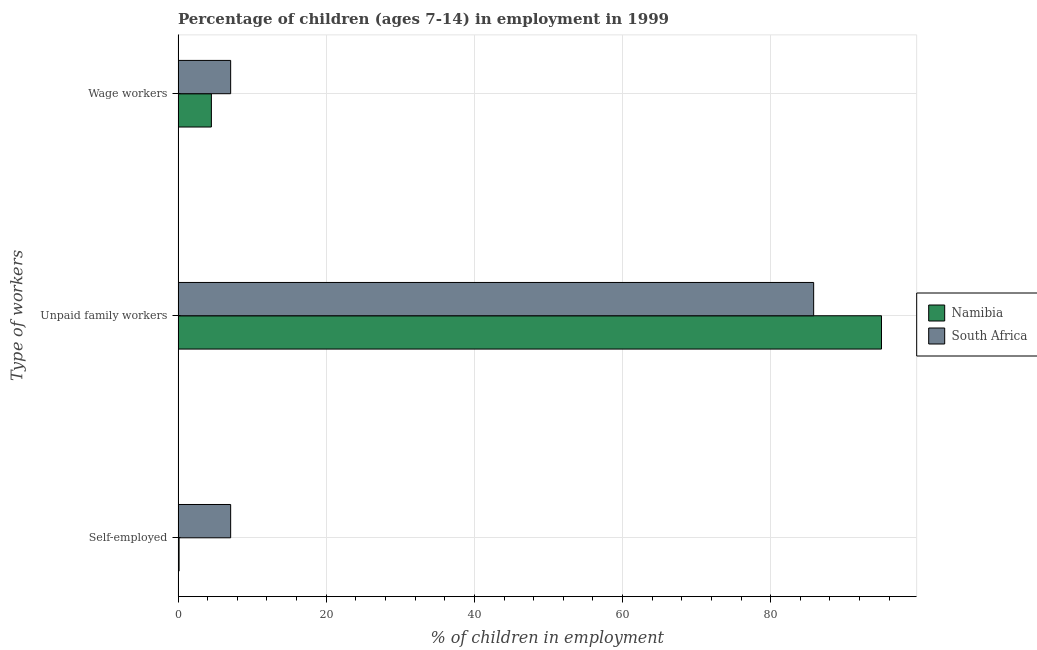How many groups of bars are there?
Provide a succinct answer. 3. Are the number of bars on each tick of the Y-axis equal?
Your response must be concise. Yes. How many bars are there on the 3rd tick from the top?
Keep it short and to the point. 2. How many bars are there on the 1st tick from the bottom?
Your answer should be compact. 2. What is the label of the 2nd group of bars from the top?
Give a very brief answer. Unpaid family workers. Across all countries, what is the maximum percentage of self employed children?
Make the answer very short. 7.1. In which country was the percentage of children employed as wage workers maximum?
Your response must be concise. South Africa. In which country was the percentage of children employed as wage workers minimum?
Offer a terse response. Namibia. What is the difference between the percentage of children employed as wage workers in South Africa and that in Namibia?
Provide a succinct answer. 2.6. What is the difference between the percentage of children employed as unpaid family workers in Namibia and the percentage of children employed as wage workers in South Africa?
Make the answer very short. 87.86. What is the average percentage of children employed as unpaid family workers per country?
Your answer should be compact. 90.38. What is the difference between the percentage of children employed as unpaid family workers and percentage of self employed children in South Africa?
Ensure brevity in your answer.  78.7. What is the ratio of the percentage of children employed as unpaid family workers in Namibia to that in South Africa?
Ensure brevity in your answer.  1.11. Is the difference between the percentage of self employed children in South Africa and Namibia greater than the difference between the percentage of children employed as unpaid family workers in South Africa and Namibia?
Provide a succinct answer. Yes. What is the difference between the highest and the second highest percentage of children employed as wage workers?
Ensure brevity in your answer.  2.6. What is the difference between the highest and the lowest percentage of children employed as wage workers?
Make the answer very short. 2.6. Is the sum of the percentage of self employed children in South Africa and Namibia greater than the maximum percentage of children employed as wage workers across all countries?
Give a very brief answer. Yes. What does the 2nd bar from the top in Unpaid family workers represents?
Provide a short and direct response. Namibia. What does the 2nd bar from the bottom in Wage workers represents?
Provide a short and direct response. South Africa. Is it the case that in every country, the sum of the percentage of self employed children and percentage of children employed as unpaid family workers is greater than the percentage of children employed as wage workers?
Offer a terse response. Yes. Are all the bars in the graph horizontal?
Keep it short and to the point. Yes. How many countries are there in the graph?
Your response must be concise. 2. What is the difference between two consecutive major ticks on the X-axis?
Offer a very short reply. 20. Where does the legend appear in the graph?
Your response must be concise. Center right. How many legend labels are there?
Give a very brief answer. 2. How are the legend labels stacked?
Provide a succinct answer. Vertical. What is the title of the graph?
Provide a succinct answer. Percentage of children (ages 7-14) in employment in 1999. Does "Mexico" appear as one of the legend labels in the graph?
Ensure brevity in your answer.  No. What is the label or title of the X-axis?
Your answer should be compact. % of children in employment. What is the label or title of the Y-axis?
Make the answer very short. Type of workers. What is the % of children in employment in Namibia in Self-employed?
Make the answer very short. 0.14. What is the % of children in employment of Namibia in Unpaid family workers?
Make the answer very short. 94.96. What is the % of children in employment in South Africa in Unpaid family workers?
Offer a very short reply. 85.8. What is the % of children in employment in Namibia in Wage workers?
Provide a short and direct response. 4.5. Across all Type of workers, what is the maximum % of children in employment in Namibia?
Make the answer very short. 94.96. Across all Type of workers, what is the maximum % of children in employment in South Africa?
Ensure brevity in your answer.  85.8. Across all Type of workers, what is the minimum % of children in employment of Namibia?
Ensure brevity in your answer.  0.14. What is the total % of children in employment in Namibia in the graph?
Keep it short and to the point. 99.6. What is the difference between the % of children in employment of Namibia in Self-employed and that in Unpaid family workers?
Offer a very short reply. -94.82. What is the difference between the % of children in employment of South Africa in Self-employed and that in Unpaid family workers?
Your answer should be compact. -78.7. What is the difference between the % of children in employment of Namibia in Self-employed and that in Wage workers?
Give a very brief answer. -4.36. What is the difference between the % of children in employment of Namibia in Unpaid family workers and that in Wage workers?
Keep it short and to the point. 90.46. What is the difference between the % of children in employment in South Africa in Unpaid family workers and that in Wage workers?
Offer a terse response. 78.7. What is the difference between the % of children in employment of Namibia in Self-employed and the % of children in employment of South Africa in Unpaid family workers?
Make the answer very short. -85.66. What is the difference between the % of children in employment in Namibia in Self-employed and the % of children in employment in South Africa in Wage workers?
Ensure brevity in your answer.  -6.96. What is the difference between the % of children in employment of Namibia in Unpaid family workers and the % of children in employment of South Africa in Wage workers?
Keep it short and to the point. 87.86. What is the average % of children in employment in Namibia per Type of workers?
Give a very brief answer. 33.2. What is the average % of children in employment of South Africa per Type of workers?
Give a very brief answer. 33.33. What is the difference between the % of children in employment of Namibia and % of children in employment of South Africa in Self-employed?
Ensure brevity in your answer.  -6.96. What is the difference between the % of children in employment in Namibia and % of children in employment in South Africa in Unpaid family workers?
Keep it short and to the point. 9.16. What is the difference between the % of children in employment in Namibia and % of children in employment in South Africa in Wage workers?
Make the answer very short. -2.6. What is the ratio of the % of children in employment in Namibia in Self-employed to that in Unpaid family workers?
Make the answer very short. 0. What is the ratio of the % of children in employment of South Africa in Self-employed to that in Unpaid family workers?
Provide a short and direct response. 0.08. What is the ratio of the % of children in employment in Namibia in Self-employed to that in Wage workers?
Give a very brief answer. 0.03. What is the ratio of the % of children in employment in South Africa in Self-employed to that in Wage workers?
Offer a terse response. 1. What is the ratio of the % of children in employment in Namibia in Unpaid family workers to that in Wage workers?
Offer a very short reply. 21.1. What is the ratio of the % of children in employment of South Africa in Unpaid family workers to that in Wage workers?
Your answer should be very brief. 12.08. What is the difference between the highest and the second highest % of children in employment in Namibia?
Your answer should be compact. 90.46. What is the difference between the highest and the second highest % of children in employment of South Africa?
Provide a short and direct response. 78.7. What is the difference between the highest and the lowest % of children in employment of Namibia?
Your answer should be compact. 94.82. What is the difference between the highest and the lowest % of children in employment of South Africa?
Your answer should be compact. 78.7. 